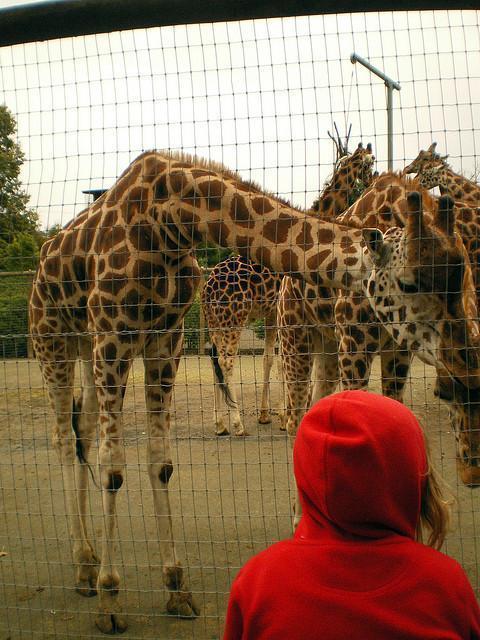How many of the giraffes are attentive to the child?
Choose the correct response and explain in the format: 'Answer: answer
Rationale: rationale.'
Options: Three, two, four, one. Answer: two.
Rationale: Two giraffes are near the child. 